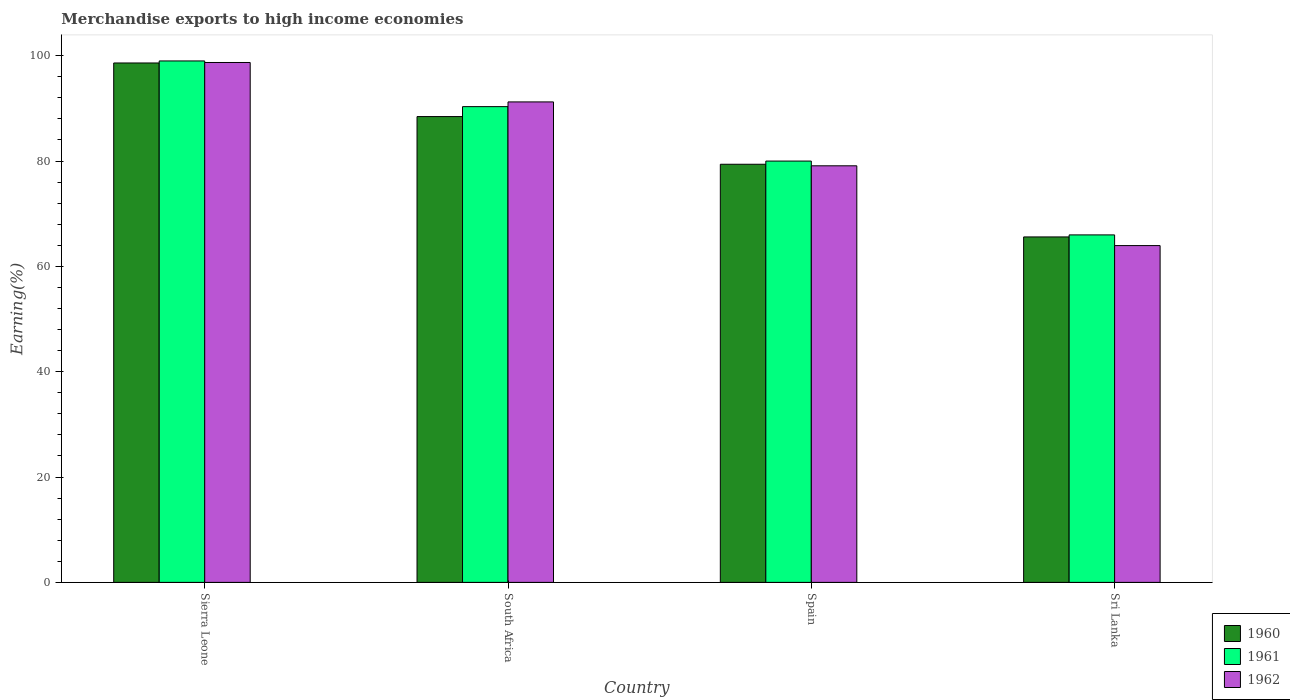How many groups of bars are there?
Make the answer very short. 4. Are the number of bars per tick equal to the number of legend labels?
Offer a terse response. Yes. How many bars are there on the 2nd tick from the left?
Offer a terse response. 3. How many bars are there on the 3rd tick from the right?
Make the answer very short. 3. What is the label of the 2nd group of bars from the left?
Your answer should be very brief. South Africa. In how many cases, is the number of bars for a given country not equal to the number of legend labels?
Offer a very short reply. 0. What is the percentage of amount earned from merchandise exports in 1960 in Spain?
Provide a succinct answer. 79.39. Across all countries, what is the maximum percentage of amount earned from merchandise exports in 1962?
Offer a very short reply. 98.71. Across all countries, what is the minimum percentage of amount earned from merchandise exports in 1962?
Your answer should be very brief. 63.95. In which country was the percentage of amount earned from merchandise exports in 1962 maximum?
Your answer should be compact. Sierra Leone. In which country was the percentage of amount earned from merchandise exports in 1960 minimum?
Offer a terse response. Sri Lanka. What is the total percentage of amount earned from merchandise exports in 1960 in the graph?
Offer a very short reply. 332.05. What is the difference between the percentage of amount earned from merchandise exports in 1962 in Spain and that in Sri Lanka?
Your response must be concise. 15.15. What is the difference between the percentage of amount earned from merchandise exports in 1960 in Spain and the percentage of amount earned from merchandise exports in 1961 in South Africa?
Provide a short and direct response. -10.94. What is the average percentage of amount earned from merchandise exports in 1961 per country?
Make the answer very short. 83.83. What is the difference between the percentage of amount earned from merchandise exports of/in 1961 and percentage of amount earned from merchandise exports of/in 1960 in South Africa?
Ensure brevity in your answer.  1.89. In how many countries, is the percentage of amount earned from merchandise exports in 1960 greater than 52 %?
Make the answer very short. 4. What is the ratio of the percentage of amount earned from merchandise exports in 1960 in Sierra Leone to that in Spain?
Your answer should be compact. 1.24. Is the percentage of amount earned from merchandise exports in 1962 in Spain less than that in Sri Lanka?
Your answer should be compact. No. What is the difference between the highest and the second highest percentage of amount earned from merchandise exports in 1962?
Provide a short and direct response. 7.48. What is the difference between the highest and the lowest percentage of amount earned from merchandise exports in 1960?
Make the answer very short. 33.03. What does the 3rd bar from the left in South Africa represents?
Offer a terse response. 1962. What does the 3rd bar from the right in Sierra Leone represents?
Give a very brief answer. 1960. How many bars are there?
Ensure brevity in your answer.  12. Are all the bars in the graph horizontal?
Make the answer very short. No. Are the values on the major ticks of Y-axis written in scientific E-notation?
Your answer should be very brief. No. Does the graph contain grids?
Provide a short and direct response. No. How are the legend labels stacked?
Offer a terse response. Vertical. What is the title of the graph?
Provide a succinct answer. Merchandise exports to high income economies. What is the label or title of the Y-axis?
Your response must be concise. Earning(%). What is the Earning(%) of 1960 in Sierra Leone?
Provide a short and direct response. 98.62. What is the Earning(%) of 1961 in Sierra Leone?
Make the answer very short. 99.01. What is the Earning(%) in 1962 in Sierra Leone?
Provide a succinct answer. 98.71. What is the Earning(%) in 1960 in South Africa?
Your answer should be compact. 88.45. What is the Earning(%) of 1961 in South Africa?
Ensure brevity in your answer.  90.33. What is the Earning(%) of 1962 in South Africa?
Make the answer very short. 91.23. What is the Earning(%) of 1960 in Spain?
Your answer should be compact. 79.39. What is the Earning(%) of 1961 in Spain?
Give a very brief answer. 80. What is the Earning(%) of 1962 in Spain?
Provide a short and direct response. 79.1. What is the Earning(%) in 1960 in Sri Lanka?
Offer a very short reply. 65.59. What is the Earning(%) in 1961 in Sri Lanka?
Offer a terse response. 65.98. What is the Earning(%) of 1962 in Sri Lanka?
Ensure brevity in your answer.  63.95. Across all countries, what is the maximum Earning(%) of 1960?
Provide a succinct answer. 98.62. Across all countries, what is the maximum Earning(%) in 1961?
Your answer should be compact. 99.01. Across all countries, what is the maximum Earning(%) of 1962?
Give a very brief answer. 98.71. Across all countries, what is the minimum Earning(%) of 1960?
Make the answer very short. 65.59. Across all countries, what is the minimum Earning(%) in 1961?
Provide a short and direct response. 65.98. Across all countries, what is the minimum Earning(%) in 1962?
Your answer should be compact. 63.95. What is the total Earning(%) in 1960 in the graph?
Offer a terse response. 332.05. What is the total Earning(%) in 1961 in the graph?
Keep it short and to the point. 335.31. What is the total Earning(%) in 1962 in the graph?
Provide a succinct answer. 332.99. What is the difference between the Earning(%) in 1960 in Sierra Leone and that in South Africa?
Provide a short and direct response. 10.18. What is the difference between the Earning(%) of 1961 in Sierra Leone and that in South Africa?
Give a very brief answer. 8.68. What is the difference between the Earning(%) of 1962 in Sierra Leone and that in South Africa?
Make the answer very short. 7.48. What is the difference between the Earning(%) of 1960 in Sierra Leone and that in Spain?
Make the answer very short. 19.23. What is the difference between the Earning(%) of 1961 in Sierra Leone and that in Spain?
Your response must be concise. 19.01. What is the difference between the Earning(%) in 1962 in Sierra Leone and that in Spain?
Ensure brevity in your answer.  19.61. What is the difference between the Earning(%) of 1960 in Sierra Leone and that in Sri Lanka?
Give a very brief answer. 33.03. What is the difference between the Earning(%) of 1961 in Sierra Leone and that in Sri Lanka?
Your answer should be very brief. 33.03. What is the difference between the Earning(%) in 1962 in Sierra Leone and that in Sri Lanka?
Offer a very short reply. 34.76. What is the difference between the Earning(%) in 1960 in South Africa and that in Spain?
Your answer should be very brief. 9.05. What is the difference between the Earning(%) of 1961 in South Africa and that in Spain?
Your response must be concise. 10.33. What is the difference between the Earning(%) in 1962 in South Africa and that in Spain?
Provide a succinct answer. 12.13. What is the difference between the Earning(%) of 1960 in South Africa and that in Sri Lanka?
Keep it short and to the point. 22.85. What is the difference between the Earning(%) of 1961 in South Africa and that in Sri Lanka?
Your answer should be very brief. 24.35. What is the difference between the Earning(%) in 1962 in South Africa and that in Sri Lanka?
Ensure brevity in your answer.  27.28. What is the difference between the Earning(%) of 1960 in Spain and that in Sri Lanka?
Your answer should be very brief. 13.8. What is the difference between the Earning(%) in 1961 in Spain and that in Sri Lanka?
Your response must be concise. 14.02. What is the difference between the Earning(%) in 1962 in Spain and that in Sri Lanka?
Offer a very short reply. 15.15. What is the difference between the Earning(%) in 1960 in Sierra Leone and the Earning(%) in 1961 in South Africa?
Your answer should be compact. 8.29. What is the difference between the Earning(%) in 1960 in Sierra Leone and the Earning(%) in 1962 in South Africa?
Provide a succinct answer. 7.39. What is the difference between the Earning(%) in 1961 in Sierra Leone and the Earning(%) in 1962 in South Africa?
Your answer should be very brief. 7.78. What is the difference between the Earning(%) in 1960 in Sierra Leone and the Earning(%) in 1961 in Spain?
Provide a short and direct response. 18.63. What is the difference between the Earning(%) in 1960 in Sierra Leone and the Earning(%) in 1962 in Spain?
Keep it short and to the point. 19.52. What is the difference between the Earning(%) of 1961 in Sierra Leone and the Earning(%) of 1962 in Spain?
Your answer should be compact. 19.91. What is the difference between the Earning(%) of 1960 in Sierra Leone and the Earning(%) of 1961 in Sri Lanka?
Offer a very short reply. 32.65. What is the difference between the Earning(%) in 1960 in Sierra Leone and the Earning(%) in 1962 in Sri Lanka?
Make the answer very short. 34.67. What is the difference between the Earning(%) of 1961 in Sierra Leone and the Earning(%) of 1962 in Sri Lanka?
Your answer should be compact. 35.06. What is the difference between the Earning(%) in 1960 in South Africa and the Earning(%) in 1961 in Spain?
Ensure brevity in your answer.  8.45. What is the difference between the Earning(%) in 1960 in South Africa and the Earning(%) in 1962 in Spain?
Your answer should be very brief. 9.35. What is the difference between the Earning(%) of 1961 in South Africa and the Earning(%) of 1962 in Spain?
Ensure brevity in your answer.  11.23. What is the difference between the Earning(%) in 1960 in South Africa and the Earning(%) in 1961 in Sri Lanka?
Provide a short and direct response. 22.47. What is the difference between the Earning(%) of 1960 in South Africa and the Earning(%) of 1962 in Sri Lanka?
Your answer should be very brief. 24.49. What is the difference between the Earning(%) in 1961 in South Africa and the Earning(%) in 1962 in Sri Lanka?
Provide a succinct answer. 26.38. What is the difference between the Earning(%) in 1960 in Spain and the Earning(%) in 1961 in Sri Lanka?
Your response must be concise. 13.41. What is the difference between the Earning(%) in 1960 in Spain and the Earning(%) in 1962 in Sri Lanka?
Your answer should be very brief. 15.44. What is the difference between the Earning(%) of 1961 in Spain and the Earning(%) of 1962 in Sri Lanka?
Your answer should be compact. 16.05. What is the average Earning(%) of 1960 per country?
Your response must be concise. 83.01. What is the average Earning(%) of 1961 per country?
Keep it short and to the point. 83.83. What is the average Earning(%) in 1962 per country?
Your answer should be compact. 83.25. What is the difference between the Earning(%) in 1960 and Earning(%) in 1961 in Sierra Leone?
Ensure brevity in your answer.  -0.38. What is the difference between the Earning(%) of 1960 and Earning(%) of 1962 in Sierra Leone?
Provide a succinct answer. -0.09. What is the difference between the Earning(%) in 1961 and Earning(%) in 1962 in Sierra Leone?
Offer a terse response. 0.29. What is the difference between the Earning(%) in 1960 and Earning(%) in 1961 in South Africa?
Provide a succinct answer. -1.89. What is the difference between the Earning(%) in 1960 and Earning(%) in 1962 in South Africa?
Provide a succinct answer. -2.78. What is the difference between the Earning(%) in 1961 and Earning(%) in 1962 in South Africa?
Your response must be concise. -0.9. What is the difference between the Earning(%) in 1960 and Earning(%) in 1961 in Spain?
Provide a succinct answer. -0.61. What is the difference between the Earning(%) in 1960 and Earning(%) in 1962 in Spain?
Give a very brief answer. 0.29. What is the difference between the Earning(%) in 1961 and Earning(%) in 1962 in Spain?
Keep it short and to the point. 0.9. What is the difference between the Earning(%) of 1960 and Earning(%) of 1961 in Sri Lanka?
Offer a very short reply. -0.38. What is the difference between the Earning(%) in 1960 and Earning(%) in 1962 in Sri Lanka?
Keep it short and to the point. 1.64. What is the difference between the Earning(%) of 1961 and Earning(%) of 1962 in Sri Lanka?
Offer a terse response. 2.03. What is the ratio of the Earning(%) in 1960 in Sierra Leone to that in South Africa?
Your answer should be very brief. 1.12. What is the ratio of the Earning(%) of 1961 in Sierra Leone to that in South Africa?
Provide a succinct answer. 1.1. What is the ratio of the Earning(%) in 1962 in Sierra Leone to that in South Africa?
Offer a terse response. 1.08. What is the ratio of the Earning(%) of 1960 in Sierra Leone to that in Spain?
Make the answer very short. 1.24. What is the ratio of the Earning(%) in 1961 in Sierra Leone to that in Spain?
Your answer should be very brief. 1.24. What is the ratio of the Earning(%) in 1962 in Sierra Leone to that in Spain?
Provide a succinct answer. 1.25. What is the ratio of the Earning(%) in 1960 in Sierra Leone to that in Sri Lanka?
Provide a succinct answer. 1.5. What is the ratio of the Earning(%) in 1961 in Sierra Leone to that in Sri Lanka?
Ensure brevity in your answer.  1.5. What is the ratio of the Earning(%) in 1962 in Sierra Leone to that in Sri Lanka?
Provide a succinct answer. 1.54. What is the ratio of the Earning(%) of 1960 in South Africa to that in Spain?
Keep it short and to the point. 1.11. What is the ratio of the Earning(%) of 1961 in South Africa to that in Spain?
Make the answer very short. 1.13. What is the ratio of the Earning(%) of 1962 in South Africa to that in Spain?
Keep it short and to the point. 1.15. What is the ratio of the Earning(%) in 1960 in South Africa to that in Sri Lanka?
Provide a succinct answer. 1.35. What is the ratio of the Earning(%) of 1961 in South Africa to that in Sri Lanka?
Keep it short and to the point. 1.37. What is the ratio of the Earning(%) of 1962 in South Africa to that in Sri Lanka?
Your response must be concise. 1.43. What is the ratio of the Earning(%) in 1960 in Spain to that in Sri Lanka?
Make the answer very short. 1.21. What is the ratio of the Earning(%) of 1961 in Spain to that in Sri Lanka?
Your answer should be compact. 1.21. What is the ratio of the Earning(%) in 1962 in Spain to that in Sri Lanka?
Provide a succinct answer. 1.24. What is the difference between the highest and the second highest Earning(%) of 1960?
Provide a short and direct response. 10.18. What is the difference between the highest and the second highest Earning(%) of 1961?
Make the answer very short. 8.68. What is the difference between the highest and the second highest Earning(%) of 1962?
Keep it short and to the point. 7.48. What is the difference between the highest and the lowest Earning(%) in 1960?
Offer a terse response. 33.03. What is the difference between the highest and the lowest Earning(%) of 1961?
Provide a short and direct response. 33.03. What is the difference between the highest and the lowest Earning(%) in 1962?
Give a very brief answer. 34.76. 